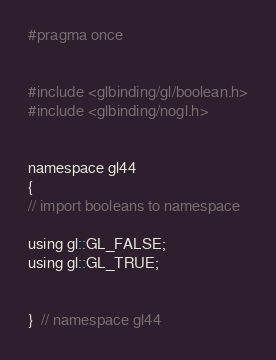Convert code to text. <code><loc_0><loc_0><loc_500><loc_500><_C_>
#pragma once


#include <glbinding/gl/boolean.h>
#include <glbinding/nogl.h>


namespace gl44
{
// import booleans to namespace

using gl::GL_FALSE;
using gl::GL_TRUE;


}  // namespace gl44
</code> 